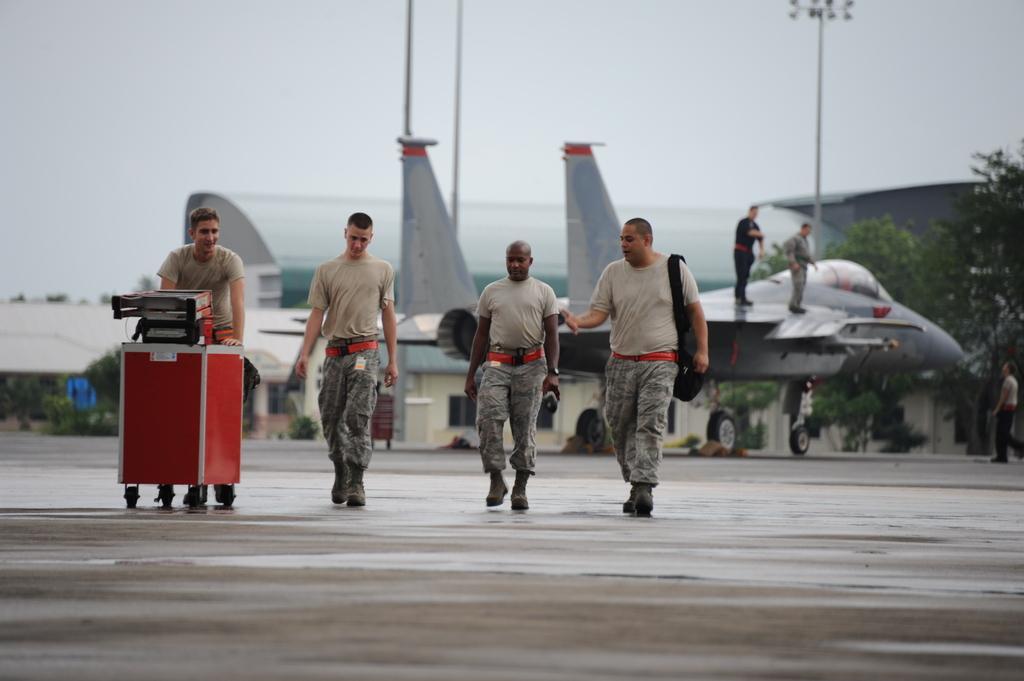Describe this image in one or two sentences. In this picture there are three persons walking and there is a person holding the trolley and he is walking. At the back there are two persons standing on the aircraft. At the back there is a building and there are poles and trees. On the right side of the image there is a person walking. At the top there is sky. At the bottom there is a road. 